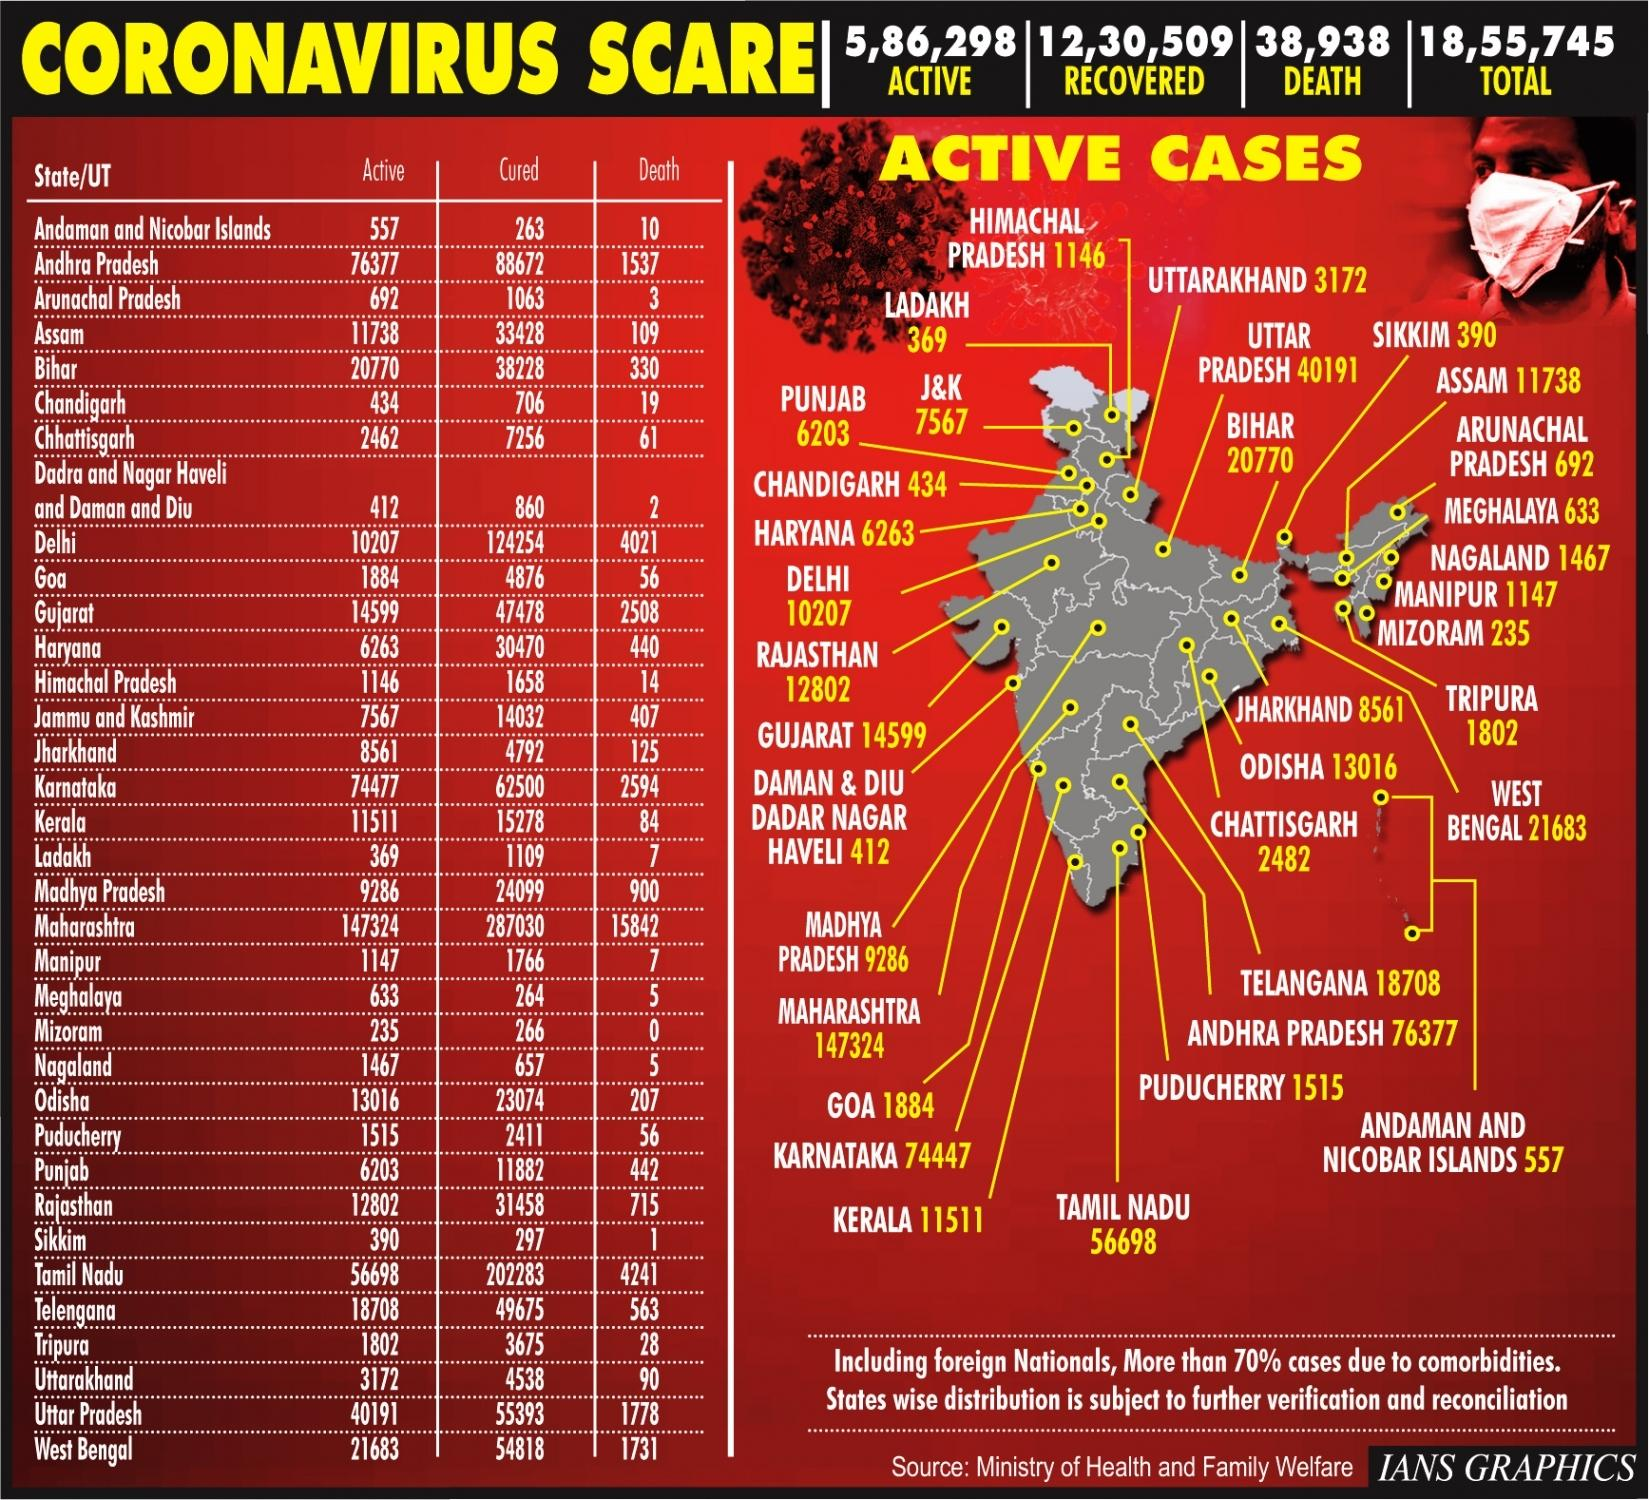Give some essential details in this illustration. Mizoram, a state in India, has not reported any deaths due to COVID-19 corona virus. As of September 2021, it is estimated that a total of 12,30,509 individuals in India have recovered from COVID-19. There were two Indian states that reported five deaths due to COVID-19 as of February 2021. As of January 30, 2023, the number of confirmed cases of COVID-19 in the northernmost union territory of India is 369. Maharashtra has the highest number of deaths due to COVID-19 in India. 